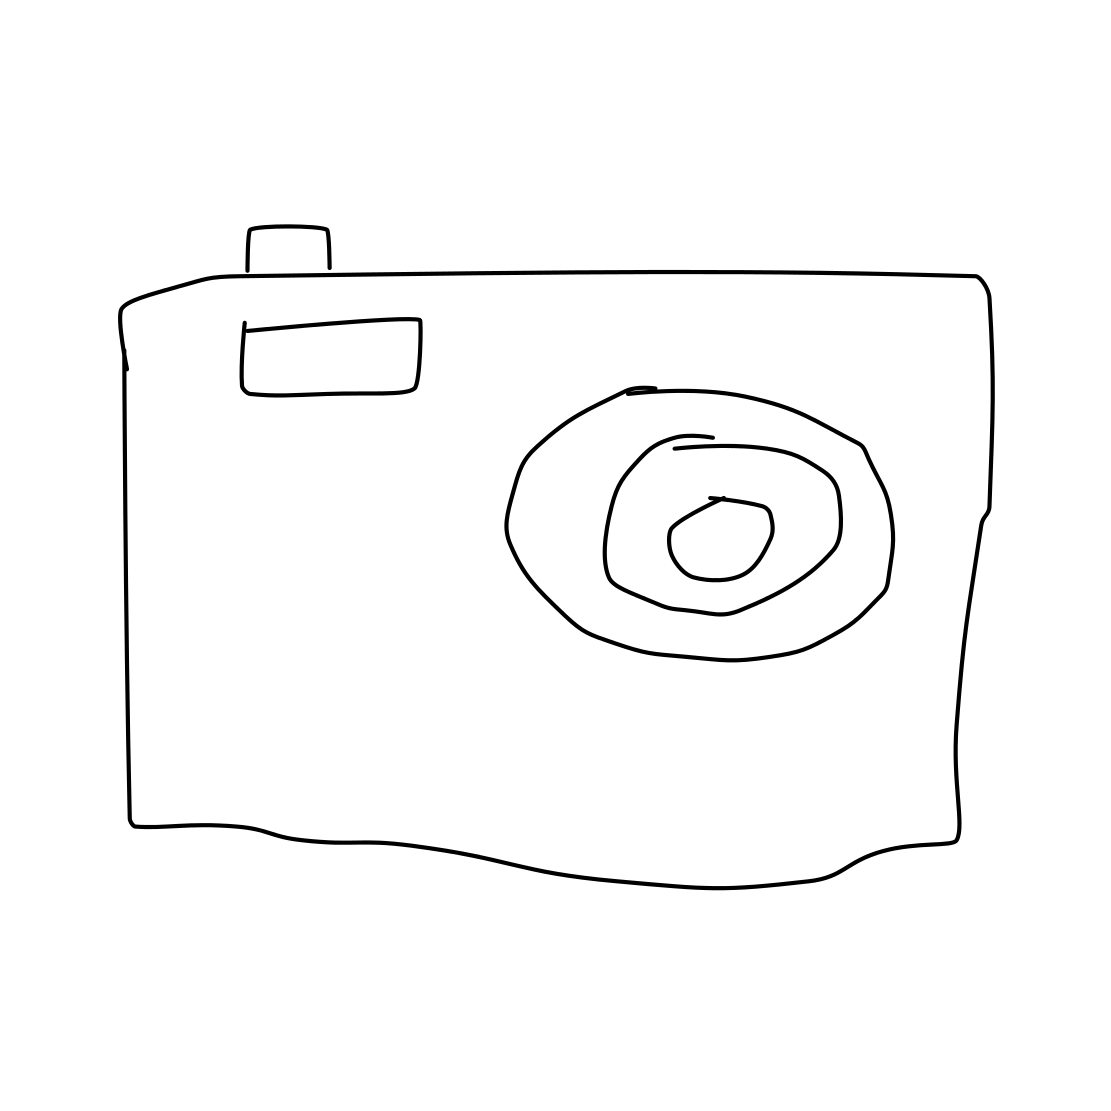Can you describe the object in this image? Certainly. The image presents a line drawing of a camera, characterized by its simplistic design. It features the basic elements one would expect — a lens in the center, viewfinder at the top, and possibly a flash unit. 